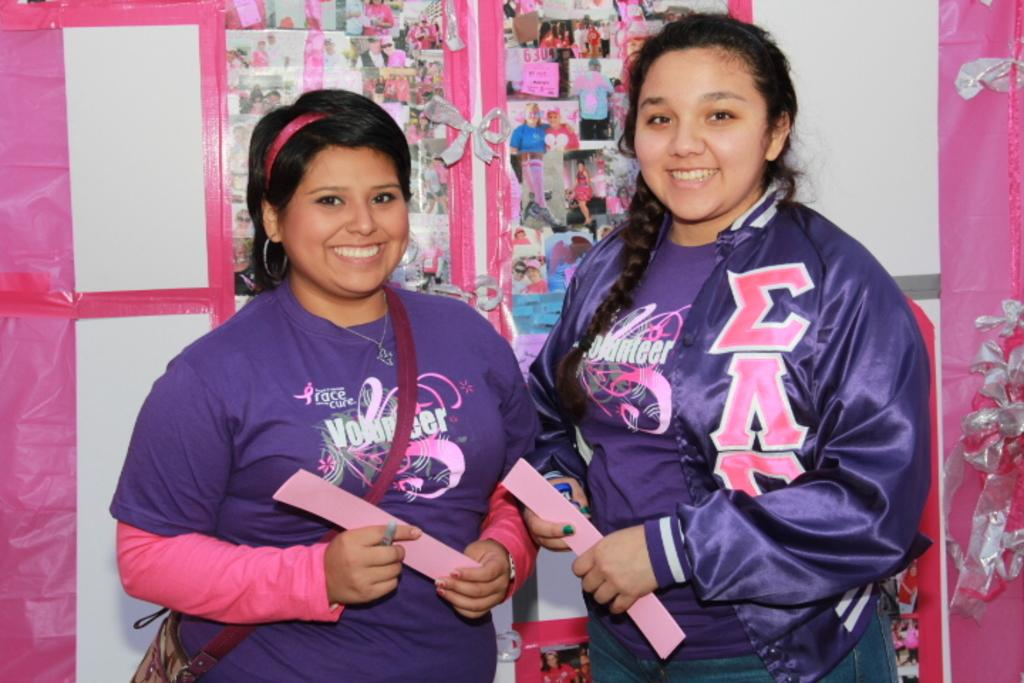<image>
Provide a brief description of the given image. Two female volunteers pose for a photo wearing race for a cure shirts. 